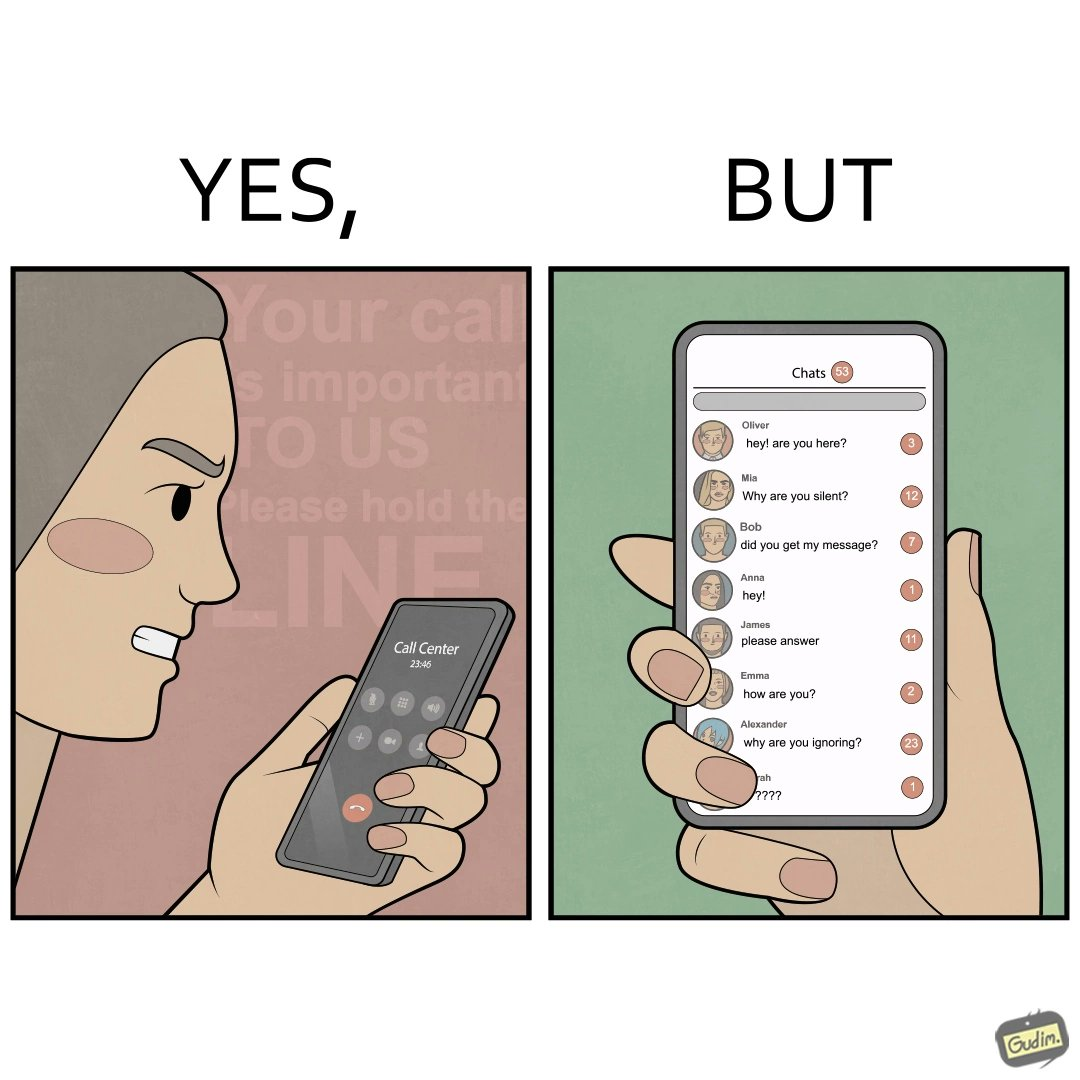What do you see in each half of this image? In the left part of the image: The image shows an annoyed woman talking to the representative in the call center on her mobile phone for over 23 minutes and 45 seconds. In the right part of the image: The image shows the chats of a person on their phone. There are a total of 53 unread chats. In the unanswered chats, the people on the other end are asking if this person got their message or if this person is ignoring them. 